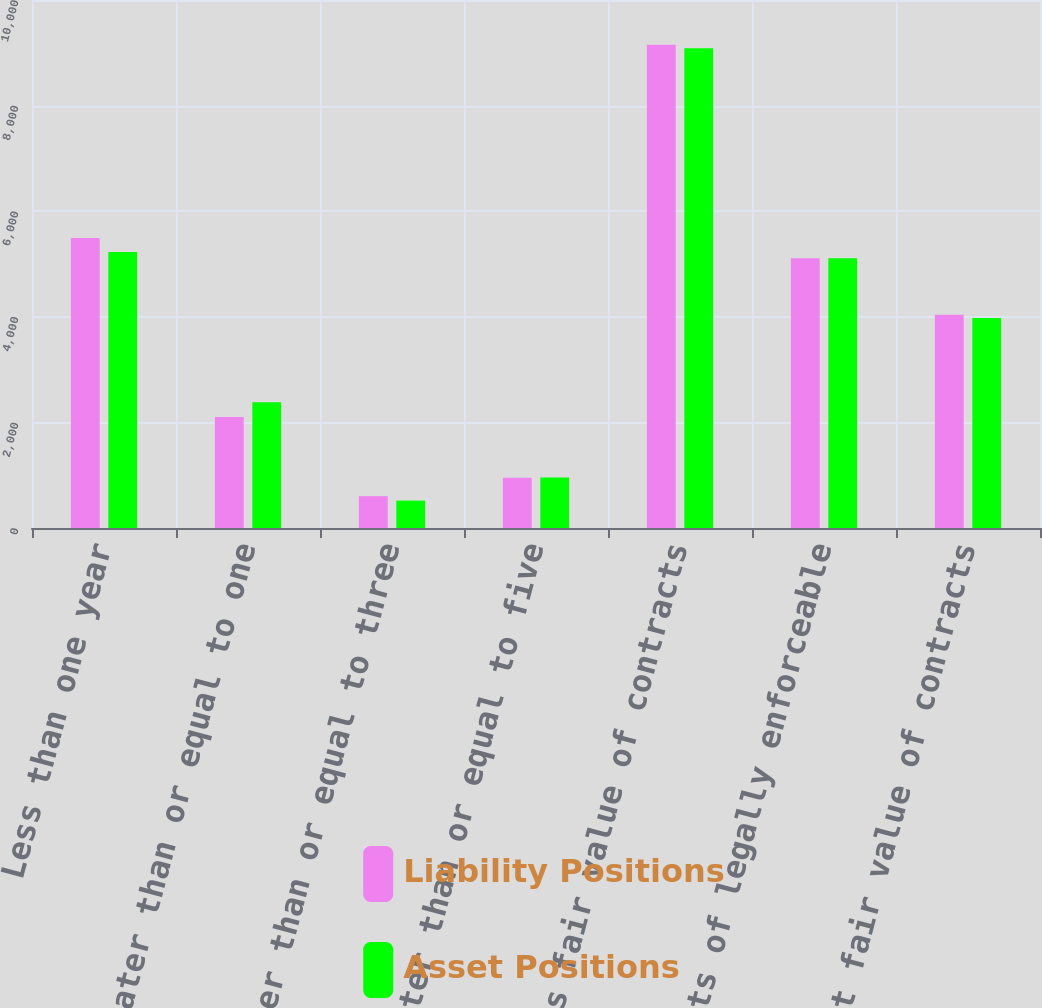Convert chart to OTSL. <chart><loc_0><loc_0><loc_500><loc_500><stacked_bar_chart><ecel><fcel>Less than one year<fcel>Greater than or equal to one<fcel>Greater than or equal to three<fcel>Greater than or equal to five<fcel>Gross fair value of contracts<fcel>Effects of legally enforceable<fcel>Net fair value of contracts<nl><fcel>Liability Positions<fcel>5494<fcel>2103<fcel>603<fcel>951<fcel>9151<fcel>5110<fcel>4041<nl><fcel>Asset Positions<fcel>5229<fcel>2383<fcel>519<fcel>956<fcel>9087<fcel>5110<fcel>3977<nl></chart> 